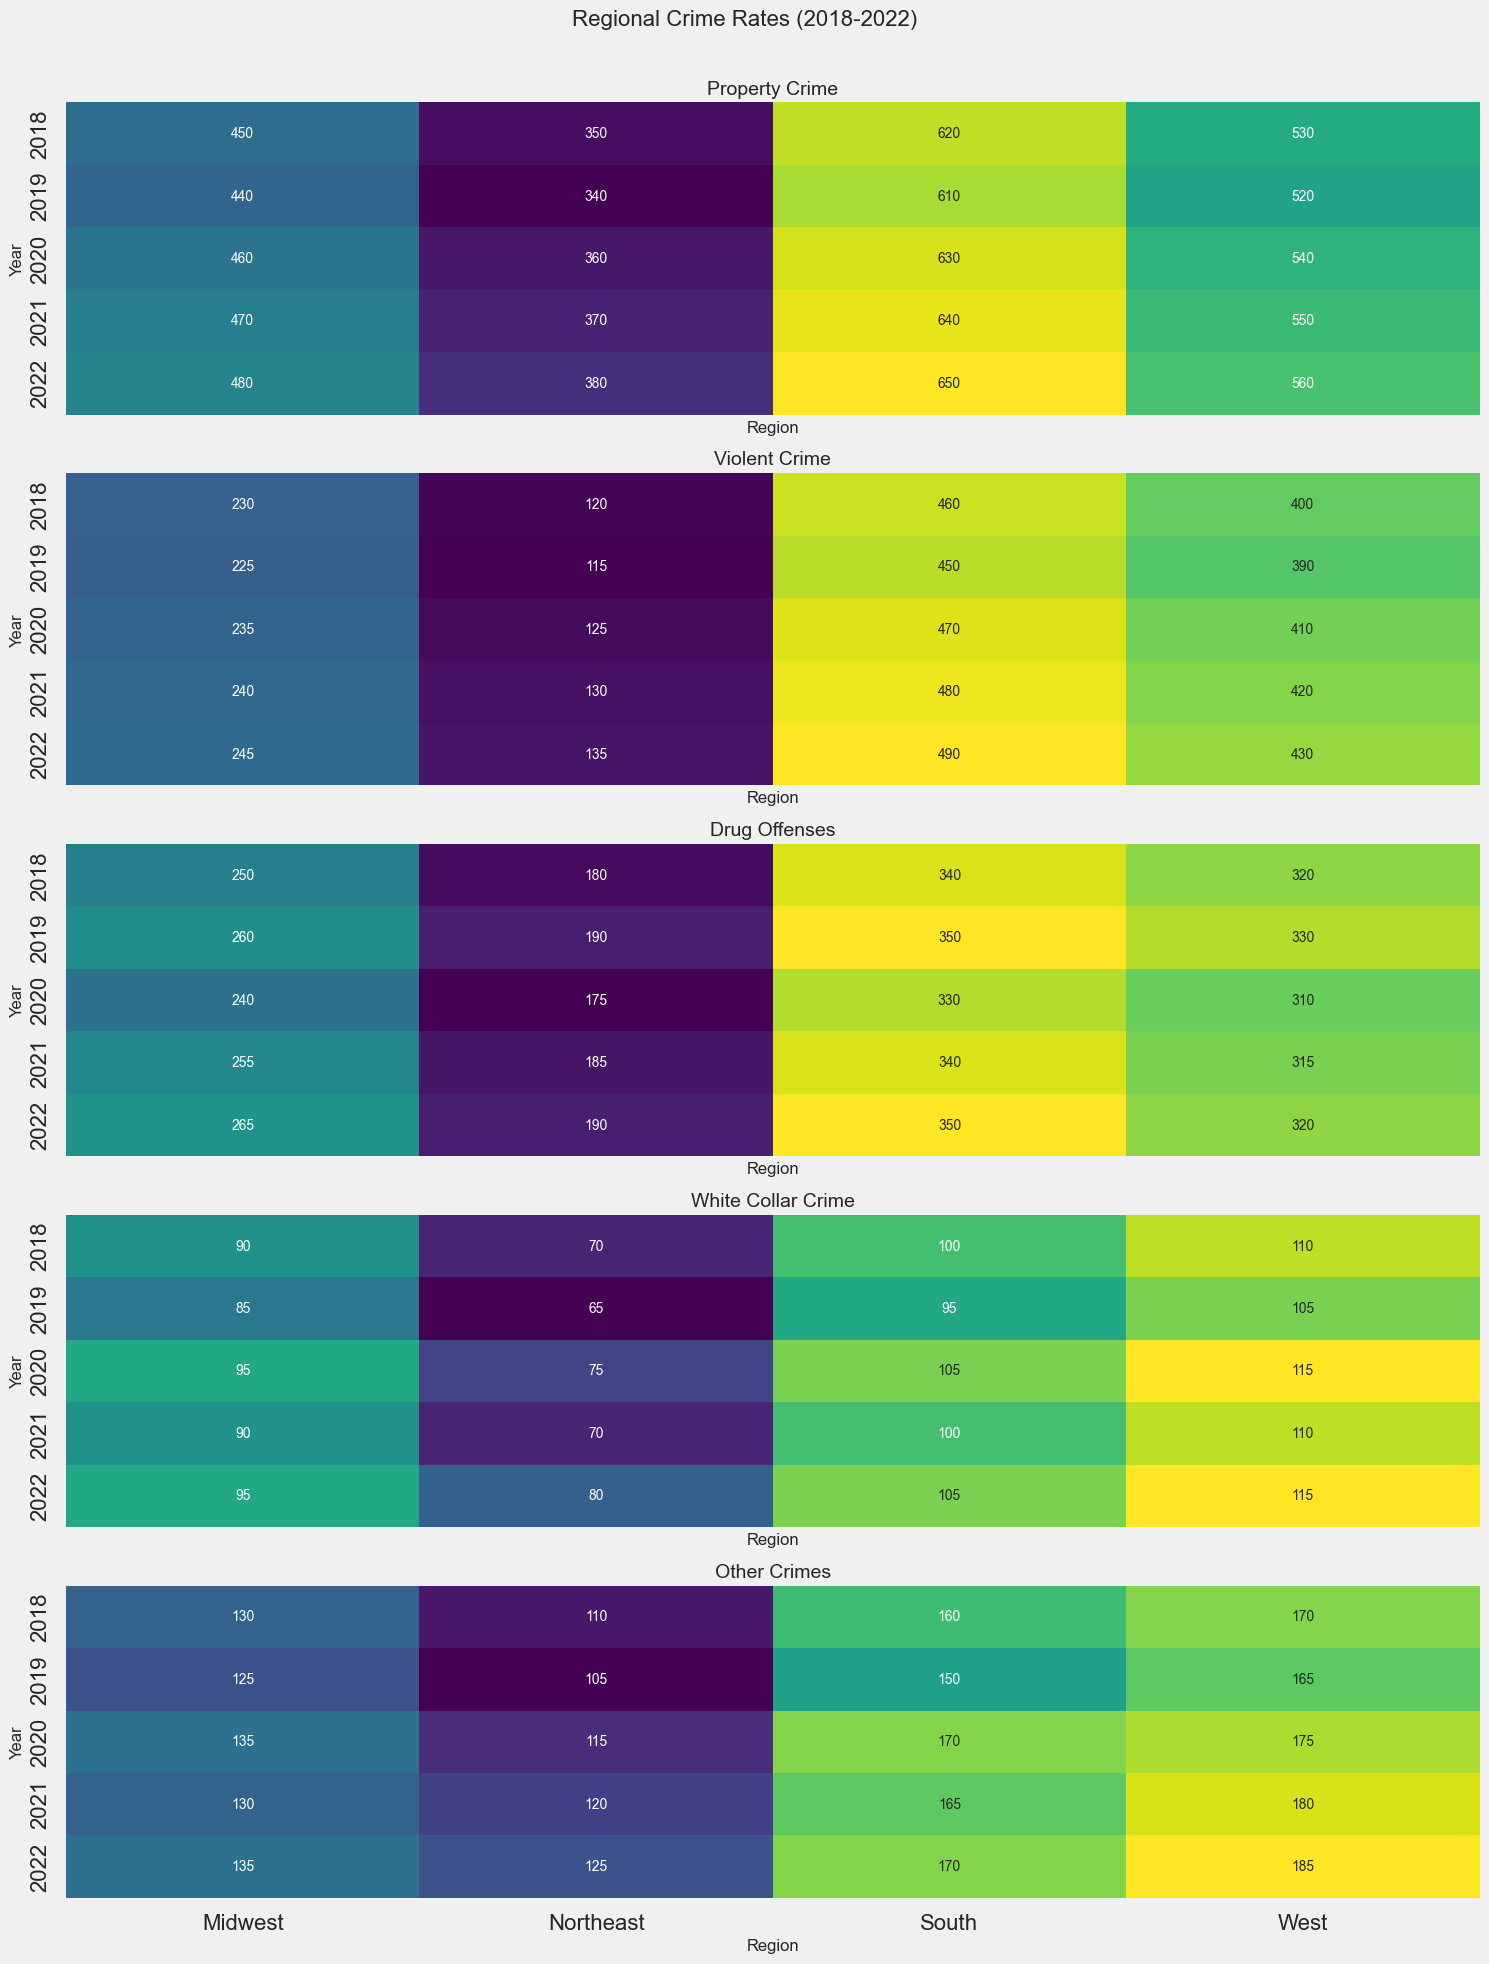What region had the highest violent crime rate in 2022? To find the region with the highest violent crime rate in 2022, look at the last row of the Violent Crime subplot and compare the values. The West region shows the highest value with 430.
Answer: West Which crime type saw the highest rate in the South region in 2020? Examine each subplot for the South region's crime rates in 2020. The highest value in each subplot corresponds to Property Crime with a value of 630.
Answer: Property Crime What is the difference in drug offenses between the Midwest and Northeast regions in 2021? Check the Drug Offenses subplot for values in the Midwest and Northeast regions in 2021. Subtract the Midwest value (255) from the Northeast value (185). The difference is 255 - 185 = 70.
Answer: 70 Which region shows a consistent increase in Property Crime from 2018 to 2022? Analyze the Property Crime subplot for each region between the years 2018 and 2022. The South region shows consistently increasing values (620, 610, 630, 640, 650).
Answer: South Compare the other crimes rate between the Northeast and West regions in 2019. Which region had a greater rate? Look at the Other Crimes subplot for 2019, comparing values for the Northeast (105) and West (165). The West region has a greater rate.
Answer: West What is the average violent crime rate across all regions in 2019? Calculate the average from the Violent Crime rates for all regions in 2019. The values are 115, 225, 450, and 390. Summing these, we get 115 + 225 + 450 + 390 = 1180. Divide by 4, which results in an average of 295.
Answer: 295 What crime type and year had the smallest rate in the Midwest? Examine the entire Midwest row across all subplots for the smallest value. The smallest value is 85, corresponding to Drug Offenses in 2019.
Answer: Drug Offenses in 2019 What is the trend in white-collar crime in the West region from 2018 to 2022? Analyze the White Collar Crime subplot for the West region across the years. The values (110, 105, 115, 110, 115) show a non-consistent pattern but generally hover around a central value without large variations.
Answer: Flat/Stable How does the rate of property crime in the Northeast in 2022 compare to the rate in 2018? Review the Property Crime values for the Northeast in 2018 (350) and 2022 (380). The 2022 rate is 380, which is an increase from the 2018 rate of 350.
Answer: Higher in 2022 What is the sum of drug offenses in the South region over the five years? Add the Drug Offenses values for the South region over five years: 340 + 350 + 330 + 340 + 350. The total is 1710.
Answer: 1710 